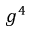<formula> <loc_0><loc_0><loc_500><loc_500>g ^ { 4 }</formula> 